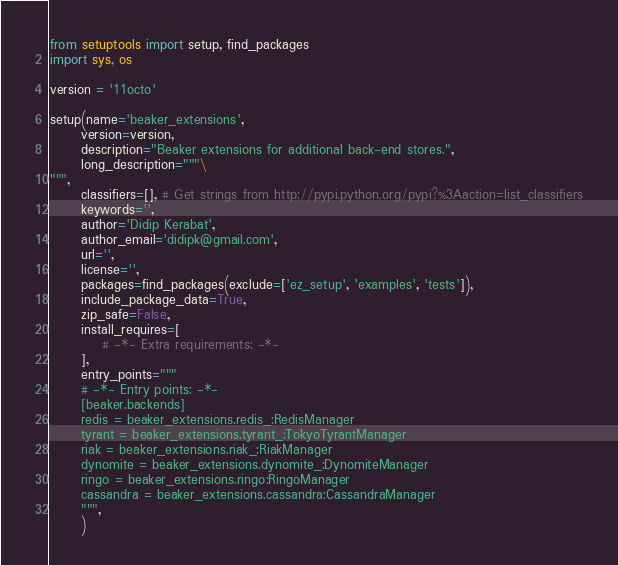<code> <loc_0><loc_0><loc_500><loc_500><_Python_>from setuptools import setup, find_packages
import sys, os

version = '11octo'

setup(name='beaker_extensions',
      version=version,
      description="Beaker extensions for additional back-end stores.",
      long_description="""\
""",
      classifiers=[], # Get strings from http://pypi.python.org/pypi?%3Aaction=list_classifiers
      keywords='',
      author='Didip Kerabat',
      author_email='didipk@gmail.com',
      url='',
      license='',
      packages=find_packages(exclude=['ez_setup', 'examples', 'tests']),
      include_package_data=True,
      zip_safe=False,
      install_requires=[
          # -*- Extra requirements: -*-
      ],
      entry_points="""
      # -*- Entry points: -*-
      [beaker.backends]
      redis = beaker_extensions.redis_:RedisManager
      tyrant = beaker_extensions.tyrant_:TokyoTyrantManager
      riak = beaker_extensions.riak_:RiakManager
      dynomite = beaker_extensions.dynomite_:DynomiteManager
      ringo = beaker_extensions.ringo:RingoManager
      cassandra = beaker_extensions.cassandra:CassandraManager
      """,
      )
</code> 